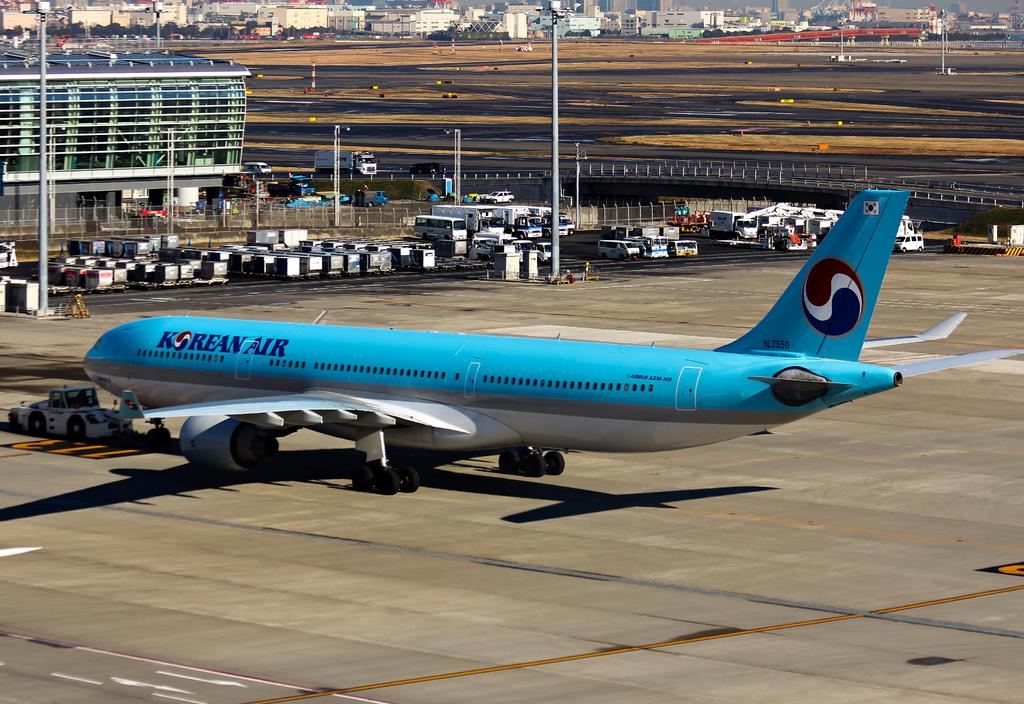What color is the airplane in the image? The airplane in the image is blue. What is located at the bottom of the image? There is a road at the bottom of the image. What can be seen in the background of the image? There are many vehicles in the background of the image. What structure is located to the left of the image? There is a building to the left of the image. What is the texture of the orange in the image? There is no orange present in the image, so it is not possible to determine its texture. 